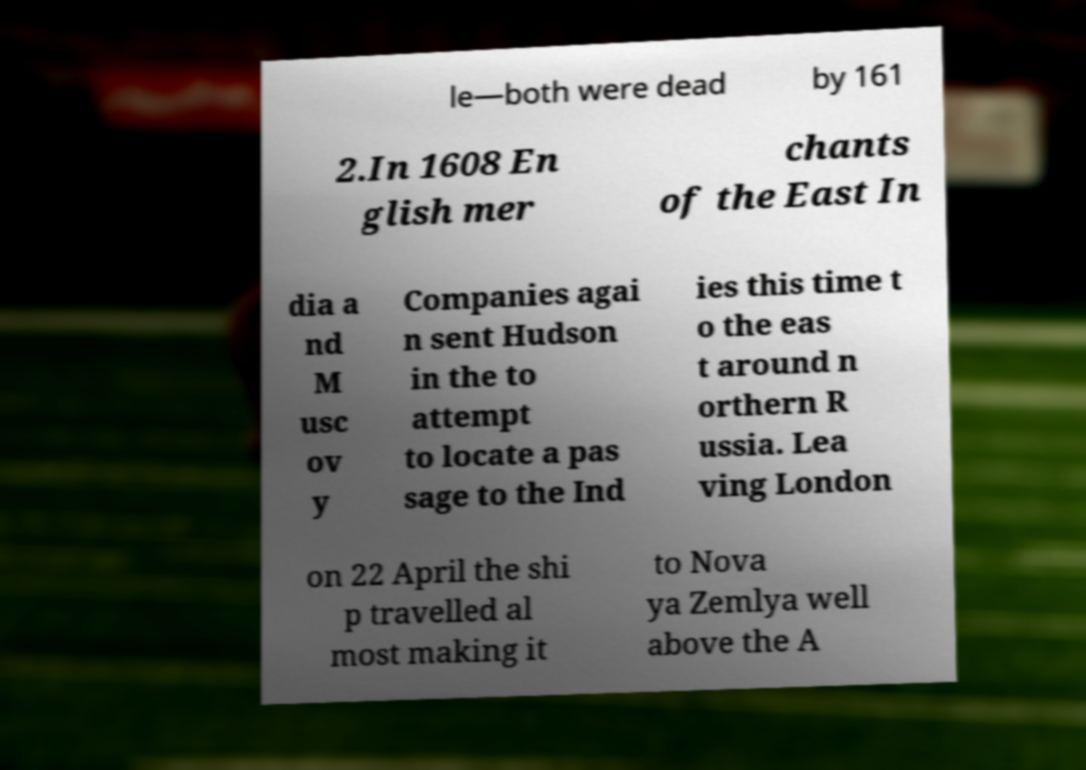Please identify and transcribe the text found in this image. The text on the paper appears to reference historical events involving English merchants and explorers. It mentions the date 1608 and the sending of Hudson likely referring to the explorer Henry Hudson, in an attempt to find a passage to the Indies, possibly the Northeast Passage around Russia. The last visible parts of the text mention a departure from London on 22 April and a ship traveling close to 'Nova Zemlya,' an archipelago in the Arctic Ocean. Due to the cutoff text, a complete and accurate transcription cannot be provided. 